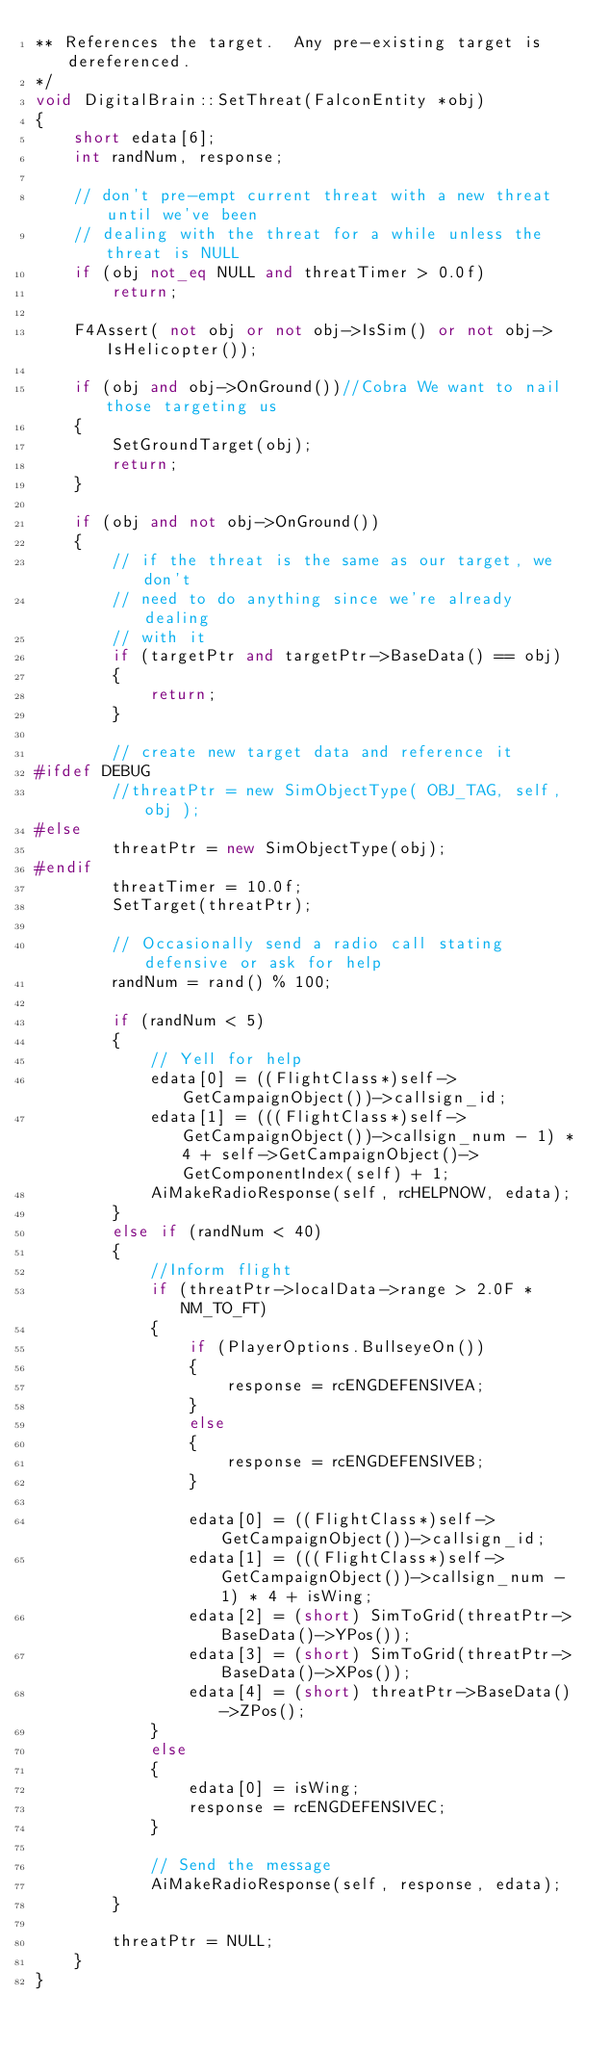Convert code to text. <code><loc_0><loc_0><loc_500><loc_500><_C++_>** References the target.  Any pre-existing target is dereferenced.
*/
void DigitalBrain::SetThreat(FalconEntity *obj)
{
    short edata[6];
    int randNum, response;

    // don't pre-empt current threat with a new threat until we've been
    // dealing with the threat for a while unless the threat is NULL
    if (obj not_eq NULL and threatTimer > 0.0f)
        return;

    F4Assert( not obj or not obj->IsSim() or not obj->IsHelicopter());

    if (obj and obj->OnGround())//Cobra We want to nail those targeting us
    {
        SetGroundTarget(obj);
        return;
    }

    if (obj and not obj->OnGround())
    {
        // if the threat is the same as our target, we don't
        // need to do anything since we're already dealing
        // with it
        if (targetPtr and targetPtr->BaseData() == obj)
        {
            return;
        }

        // create new target data and reference it
#ifdef DEBUG
        //threatPtr = new SimObjectType( OBJ_TAG, self, obj );
#else
        threatPtr = new SimObjectType(obj);
#endif
        threatTimer = 10.0f;
        SetTarget(threatPtr);

        // Occasionally send a radio call stating defensive or ask for help
        randNum = rand() % 100;

        if (randNum < 5)
        {
            // Yell for help
            edata[0] = ((FlightClass*)self->GetCampaignObject())->callsign_id;
            edata[1] = (((FlightClass*)self->GetCampaignObject())->callsign_num - 1) * 4 + self->GetCampaignObject()->GetComponentIndex(self) + 1;
            AiMakeRadioResponse(self, rcHELPNOW, edata);
        }
        else if (randNum < 40)
        {
            //Inform flight
            if (threatPtr->localData->range > 2.0F * NM_TO_FT)
            {
                if (PlayerOptions.BullseyeOn())
                {
                    response = rcENGDEFENSIVEA;
                }
                else
                {
                    response = rcENGDEFENSIVEB;
                }

                edata[0] = ((FlightClass*)self->GetCampaignObject())->callsign_id;
                edata[1] = (((FlightClass*)self->GetCampaignObject())->callsign_num - 1) * 4 + isWing;
                edata[2] = (short) SimToGrid(threatPtr->BaseData()->YPos());
                edata[3] = (short) SimToGrid(threatPtr->BaseData()->XPos());
                edata[4] = (short) threatPtr->BaseData()->ZPos();
            }
            else
            {
                edata[0] = isWing;
                response = rcENGDEFENSIVEC;
            }

            // Send the message
            AiMakeRadioResponse(self, response, edata);
        }

        threatPtr = NULL;
    }
}
</code> 